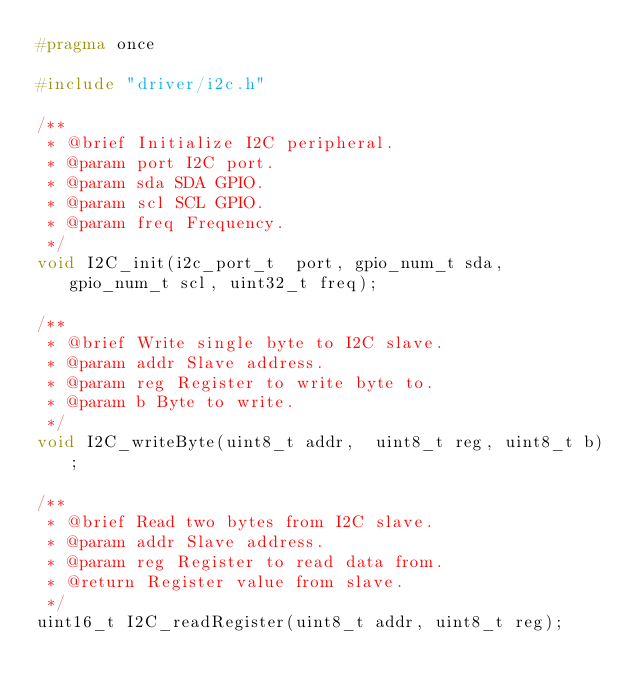<code> <loc_0><loc_0><loc_500><loc_500><_C++_>#pragma once

#include "driver/i2c.h"

/**
 * @brief Initialize I2C peripheral.
 * @param port I2C port.
 * @param sda SDA GPIO.
 * @param scl SCL GPIO.
 * @param freq Frequency.
 */
void I2C_init(i2c_port_t  port, gpio_num_t sda, gpio_num_t scl, uint32_t freq);

/**
 * @brief Write single byte to I2C slave.
 * @param addr Slave address.
 * @param reg Register to write byte to.
 * @param b Byte to write.
 */
void I2C_writeByte(uint8_t addr,  uint8_t reg, uint8_t b);

/**
 * @brief Read two bytes from I2C slave.
 * @param addr Slave address.
 * @param reg Register to read data from.
 * @return Register value from slave.
 */
uint16_t I2C_readRegister(uint8_t addr, uint8_t reg);</code> 